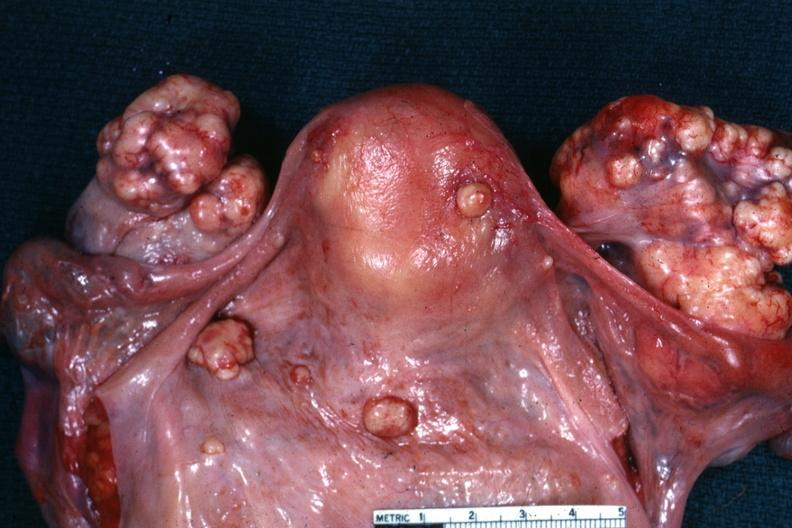what is true bilateral krukenberg?
Answer the question using a single word or phrase. This 